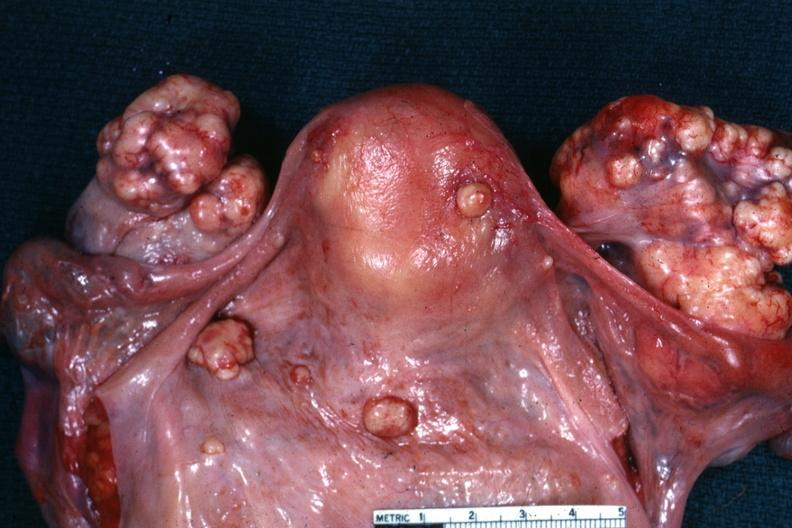what is true bilateral krukenberg?
Answer the question using a single word or phrase. This 